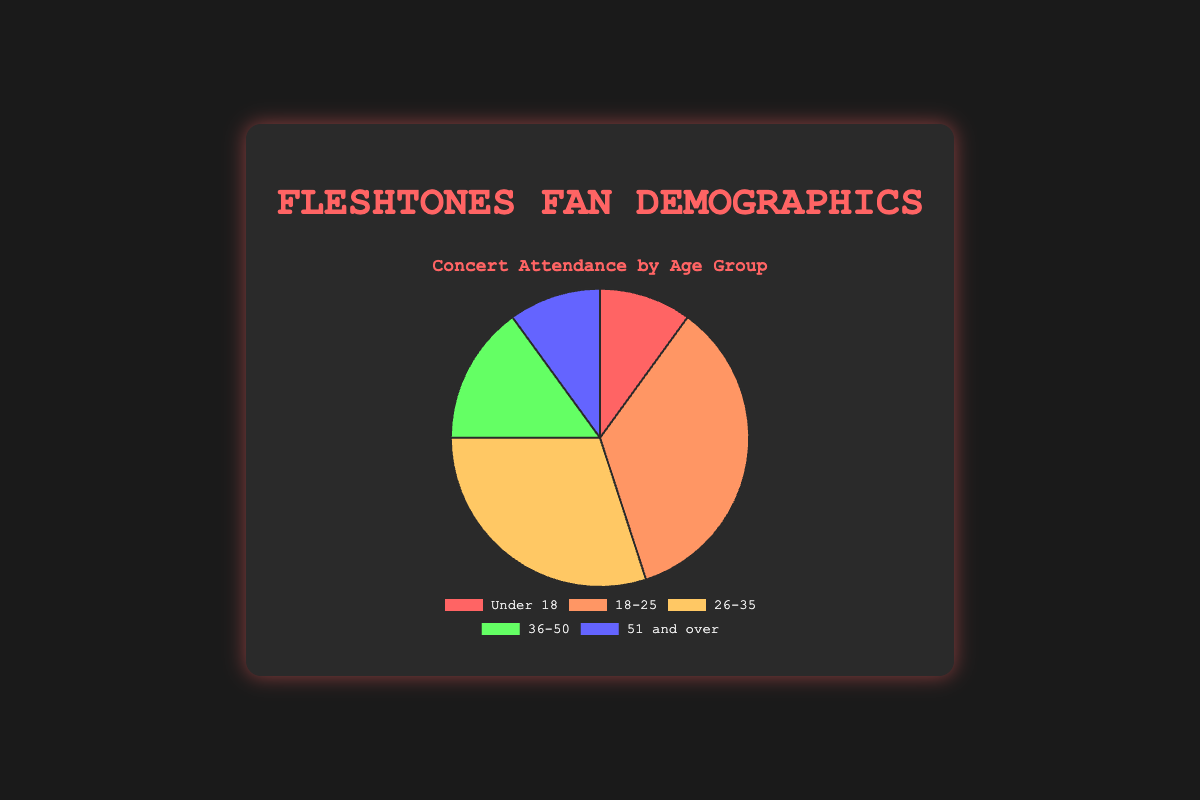What age group has the highest percentage attendance? The "18-25" age group has the highest percentage attendance at 35%. The pie chart visually shows this segment as the largest slice.
Answer: 18-25 Which two age groups have the same percentage of attendance? The "Under 18" and "51 and over" age groups both have an attendance percentage of 10%, as shown by their equal-sized pie chart sections.
Answer: Under 18 and 51 and over What is the total percentage of attendees aged 26 and older? Add the percentages for "26-35", "36-50", and "51 and over": 30% + 15% + 10% = 55%. This means 55% of the attendees are aged 26 and older.
Answer: 55% How do the attendance percentages of the "Under 18" and "36-50" age groups compare? The "36-50" age group has a higher attendance percentage (15%) compared to the "Under 18" group (10%). The corresponding pie chart segment for "36-50" is visually larger.
Answer: 36-50 > Under 18 What percentage of attendees is not in the "18-25" age group? Subtract the "18-25" percentage from 100%: 100% - 35% = 65%. This means 65% of attendees are in other age groups.
Answer: 65% Which age group is represented by a green segment? Based on the visual attributes provided, the "36-50" age group is represented by the green segment in the pie chart.
Answer: 36-50 What is the combined percentage of the two least represented age groups? The "Under 18" and "51 and over" age groups are each 10%. Adding them gives 10% + 10% = 20%.
Answer: 20% What's the difference in percentage attendance between the "18-25" and "26-35" groups? Subtract the percentages: 35% - 30% = 5%. The "18-25" age group has 5% more attendees than the "26-35" group.
Answer: 5% Which age group represents approximately one-third of the total attendance? The "18-25" age group, with 35%, is closest to one-third of the total attendance.
Answer: 18-25 